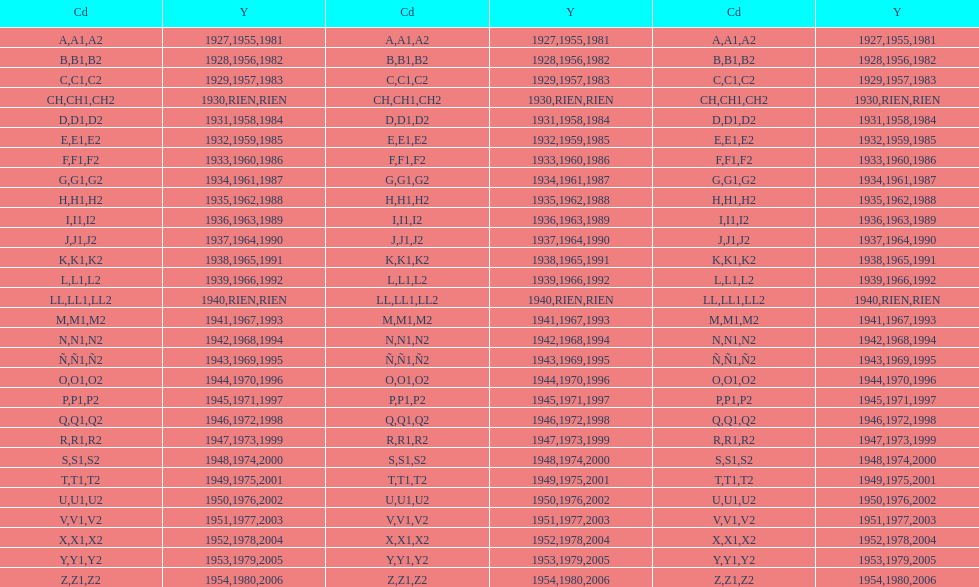How many different codes were used from 1953 to 1958? 6. Would you be able to parse every entry in this table? {'header': ['Cd', 'Y', 'Cd', 'Y', 'Cd', 'Y'], 'rows': [['A', '1927', 'A1', '1955', 'A2', '1981'], ['B', '1928', 'B1', '1956', 'B2', '1982'], ['C', '1929', 'C1', '1957', 'C2', '1983'], ['CH', '1930', 'CH1', 'RIEN', 'CH2', 'RIEN'], ['D', '1931', 'D1', '1958', 'D2', '1984'], ['E', '1932', 'E1', '1959', 'E2', '1985'], ['F', '1933', 'F1', '1960', 'F2', '1986'], ['G', '1934', 'G1', '1961', 'G2', '1987'], ['H', '1935', 'H1', '1962', 'H2', '1988'], ['I', '1936', 'I1', '1963', 'I2', '1989'], ['J', '1937', 'J1', '1964', 'J2', '1990'], ['K', '1938', 'K1', '1965', 'K2', '1991'], ['L', '1939', 'L1', '1966', 'L2', '1992'], ['LL', '1940', 'LL1', 'RIEN', 'LL2', 'RIEN'], ['M', '1941', 'M1', '1967', 'M2', '1993'], ['N', '1942', 'N1', '1968', 'N2', '1994'], ['Ñ', '1943', 'Ñ1', '1969', 'Ñ2', '1995'], ['O', '1944', 'O1', '1970', 'O2', '1996'], ['P', '1945', 'P1', '1971', 'P2', '1997'], ['Q', '1946', 'Q1', '1972', 'Q2', '1998'], ['R', '1947', 'R1', '1973', 'R2', '1999'], ['S', '1948', 'S1', '1974', 'S2', '2000'], ['T', '1949', 'T1', '1975', 'T2', '2001'], ['U', '1950', 'U1', '1976', 'U2', '2002'], ['V', '1951', 'V1', '1977', 'V2', '2003'], ['X', '1952', 'X1', '1978', 'X2', '2004'], ['Y', '1953', 'Y1', '1979', 'Y2', '2005'], ['Z', '1954', 'Z1', '1980', 'Z2', '2006']]} 